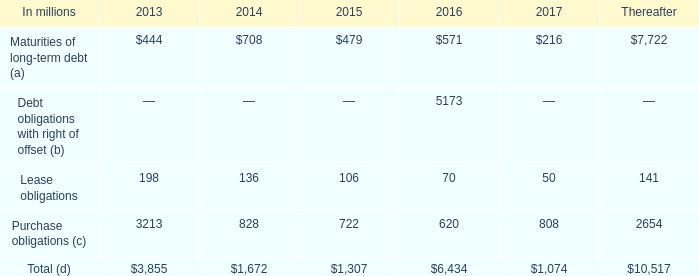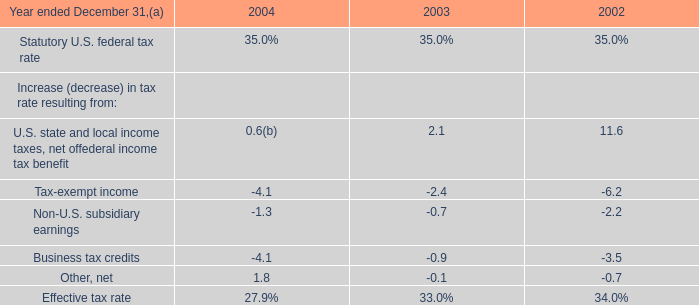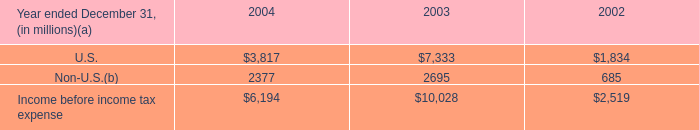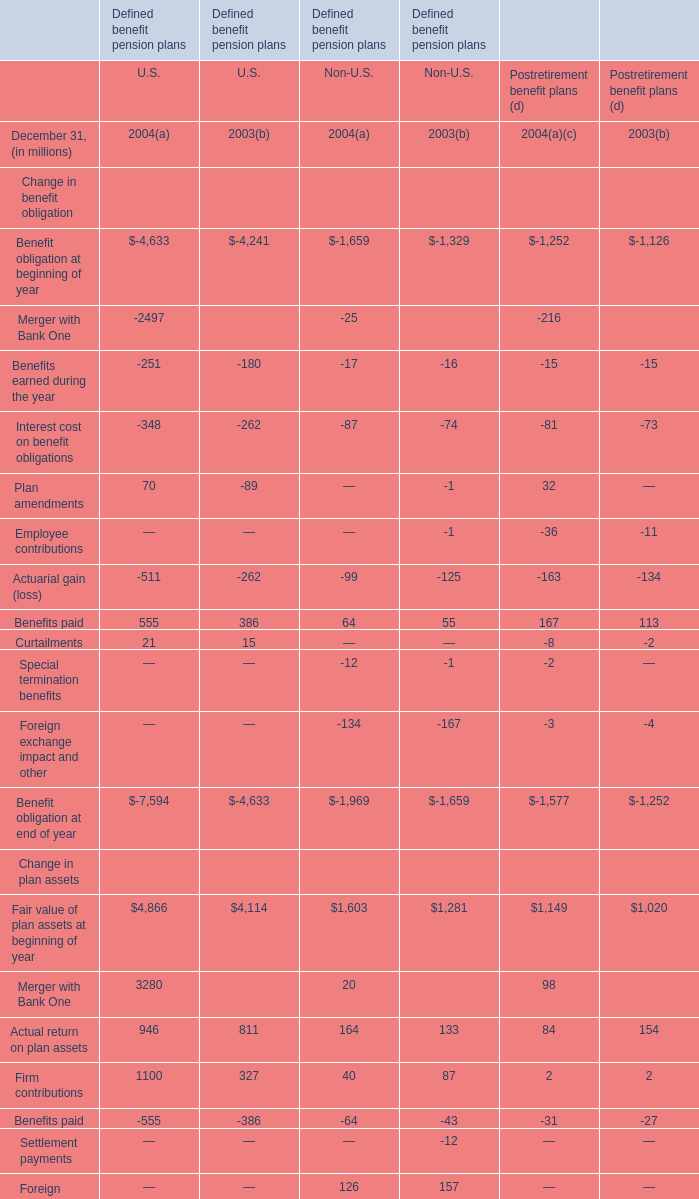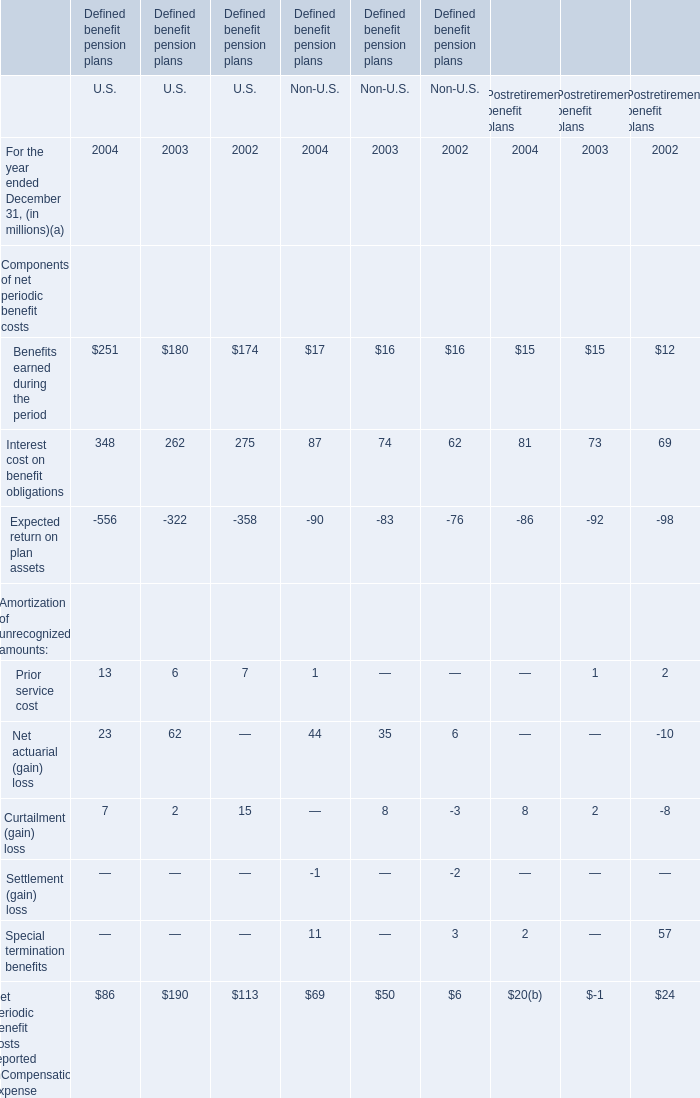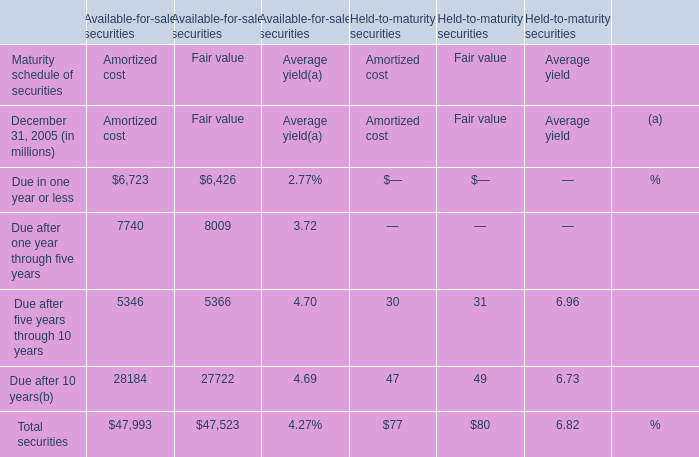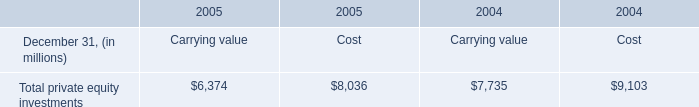What is the total amount of Net periodic benefit costs reported in Compensation expense for Non-U.S. under Defined benefit pension plans in 2004? (in million) 
Answer: 69. 